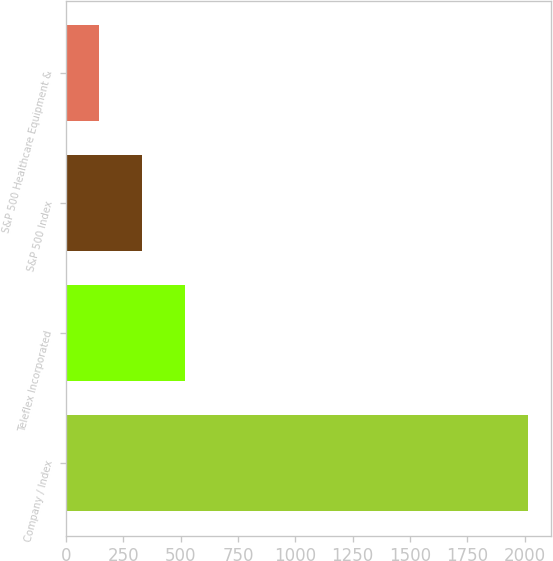<chart> <loc_0><loc_0><loc_500><loc_500><bar_chart><fcel>Company / Index<fcel>Teleflex Incorporated<fcel>S&P 500 Index<fcel>S&P 500 Healthcare Equipment &<nl><fcel>2013<fcel>517.8<fcel>330.9<fcel>144<nl></chart> 